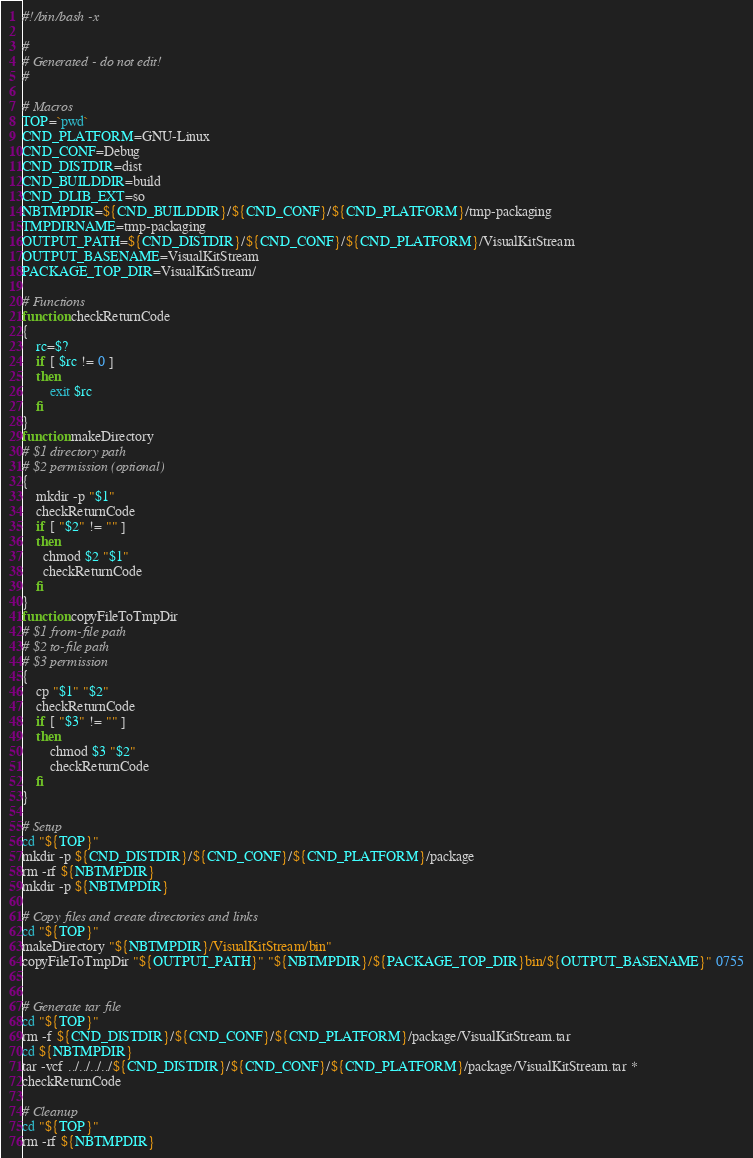<code> <loc_0><loc_0><loc_500><loc_500><_Bash_>#!/bin/bash -x

#
# Generated - do not edit!
#

# Macros
TOP=`pwd`
CND_PLATFORM=GNU-Linux
CND_CONF=Debug
CND_DISTDIR=dist
CND_BUILDDIR=build
CND_DLIB_EXT=so
NBTMPDIR=${CND_BUILDDIR}/${CND_CONF}/${CND_PLATFORM}/tmp-packaging
TMPDIRNAME=tmp-packaging
OUTPUT_PATH=${CND_DISTDIR}/${CND_CONF}/${CND_PLATFORM}/VisualKitStream
OUTPUT_BASENAME=VisualKitStream
PACKAGE_TOP_DIR=VisualKitStream/

# Functions
function checkReturnCode
{
    rc=$?
    if [ $rc != 0 ]
    then
        exit $rc
    fi
}
function makeDirectory
# $1 directory path
# $2 permission (optional)
{
    mkdir -p "$1"
    checkReturnCode
    if [ "$2" != "" ]
    then
      chmod $2 "$1"
      checkReturnCode
    fi
}
function copyFileToTmpDir
# $1 from-file path
# $2 to-file path
# $3 permission
{
    cp "$1" "$2"
    checkReturnCode
    if [ "$3" != "" ]
    then
        chmod $3 "$2"
        checkReturnCode
    fi
}

# Setup
cd "${TOP}"
mkdir -p ${CND_DISTDIR}/${CND_CONF}/${CND_PLATFORM}/package
rm -rf ${NBTMPDIR}
mkdir -p ${NBTMPDIR}

# Copy files and create directories and links
cd "${TOP}"
makeDirectory "${NBTMPDIR}/VisualKitStream/bin"
copyFileToTmpDir "${OUTPUT_PATH}" "${NBTMPDIR}/${PACKAGE_TOP_DIR}bin/${OUTPUT_BASENAME}" 0755


# Generate tar file
cd "${TOP}"
rm -f ${CND_DISTDIR}/${CND_CONF}/${CND_PLATFORM}/package/VisualKitStream.tar
cd ${NBTMPDIR}
tar -vcf ../../../../${CND_DISTDIR}/${CND_CONF}/${CND_PLATFORM}/package/VisualKitStream.tar *
checkReturnCode

# Cleanup
cd "${TOP}"
rm -rf ${NBTMPDIR}
</code> 